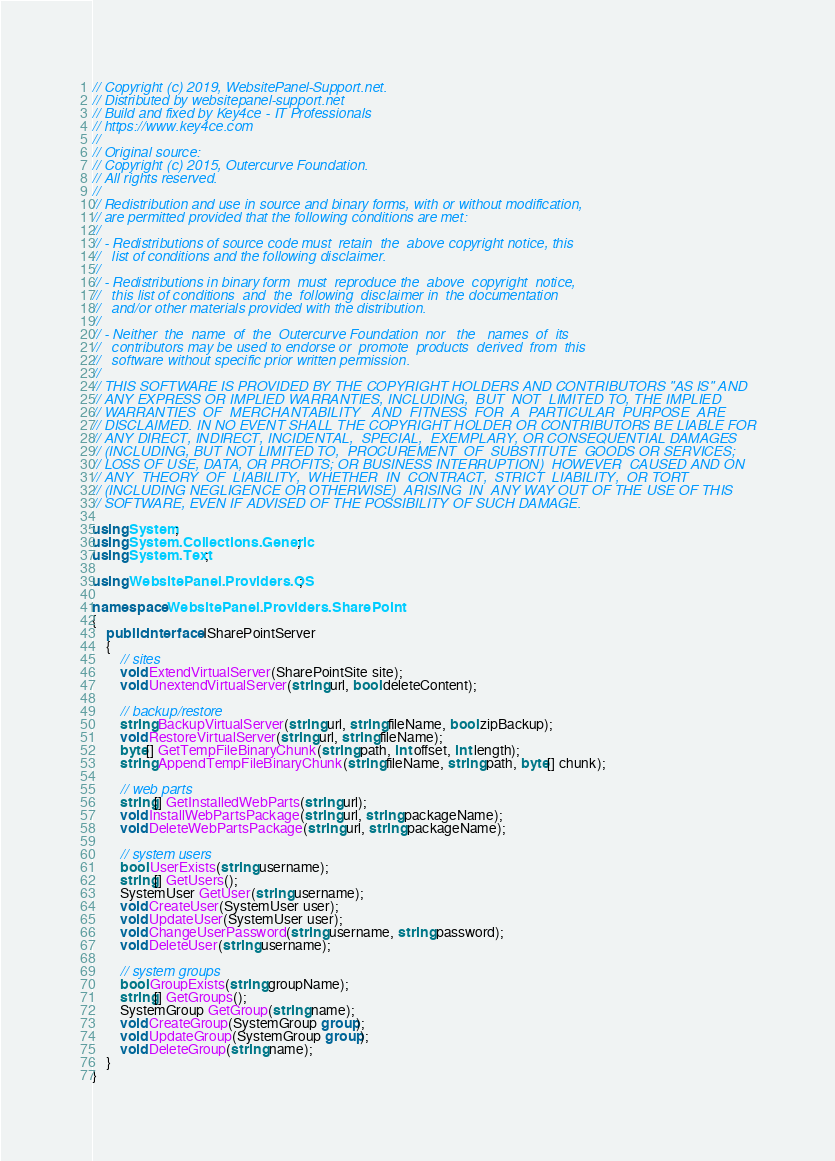<code> <loc_0><loc_0><loc_500><loc_500><_C#_>// Copyright (c) 2019, WebsitePanel-Support.net.
// Distributed by websitepanel-support.net
// Build and fixed by Key4ce - IT Professionals
// https://www.key4ce.com
// 
// Original source:
// Copyright (c) 2015, Outercurve Foundation.
// All rights reserved.
//
// Redistribution and use in source and binary forms, with or without modification,
// are permitted provided that the following conditions are met:
//
// - Redistributions of source code must  retain  the  above copyright notice, this
//   list of conditions and the following disclaimer.
//
// - Redistributions in binary form  must  reproduce the  above  copyright  notice,
//   this list of conditions  and  the  following  disclaimer in  the documentation
//   and/or other materials provided with the distribution.
//
// - Neither  the  name  of  the  Outercurve Foundation  nor   the   names  of  its
//   contributors may be used to endorse or  promote  products  derived  from  this
//   software without specific prior written permission.
//
// THIS SOFTWARE IS PROVIDED BY THE COPYRIGHT HOLDERS AND CONTRIBUTORS "AS IS" AND
// ANY EXPRESS OR IMPLIED WARRANTIES, INCLUDING,  BUT  NOT  LIMITED TO, THE IMPLIED
// WARRANTIES  OF  MERCHANTABILITY   AND  FITNESS  FOR  A  PARTICULAR  PURPOSE  ARE
// DISCLAIMED. IN NO EVENT SHALL THE COPYRIGHT HOLDER OR CONTRIBUTORS BE LIABLE FOR
// ANY DIRECT, INDIRECT, INCIDENTAL,  SPECIAL,  EXEMPLARY, OR CONSEQUENTIAL DAMAGES
// (INCLUDING, BUT NOT LIMITED TO,  PROCUREMENT  OF  SUBSTITUTE  GOODS OR SERVICES;
// LOSS OF USE, DATA, OR PROFITS; OR BUSINESS INTERRUPTION)  HOWEVER  CAUSED AND ON
// ANY  THEORY  OF  LIABILITY,  WHETHER  IN  CONTRACT,  STRICT  LIABILITY,  OR TORT
// (INCLUDING NEGLIGENCE OR OTHERWISE)  ARISING  IN  ANY WAY OUT OF THE USE OF THIS
// SOFTWARE, EVEN IF ADVISED OF THE POSSIBILITY OF SUCH DAMAGE.

using System;
using System.Collections.Generic;
using System.Text;

using WebsitePanel.Providers.OS;

namespace WebsitePanel.Providers.SharePoint
{
    public interface ISharePointServer
    {
        // sites
        void ExtendVirtualServer(SharePointSite site);
        void UnextendVirtualServer(string url, bool deleteContent);

        // backup/restore
        string BackupVirtualServer(string url, string fileName, bool zipBackup);
        void RestoreVirtualServer(string url, string fileName);
        byte[] GetTempFileBinaryChunk(string path, int offset, int length);
        string AppendTempFileBinaryChunk(string fileName, string path, byte[] chunk);

        // web parts
        string[] GetInstalledWebParts(string url);
        void InstallWebPartsPackage(string url, string packageName);
        void DeleteWebPartsPackage(string url, string packageName);

        // system users
        bool UserExists(string username);
        string[] GetUsers();
        SystemUser GetUser(string username);
        void CreateUser(SystemUser user);
        void UpdateUser(SystemUser user);
        void ChangeUserPassword(string username, string password);
        void DeleteUser(string username);

        // system groups
        bool GroupExists(string groupName);
        string[] GetGroups();
        SystemGroup GetGroup(string name);
        void CreateGroup(SystemGroup group);
        void UpdateGroup(SystemGroup group);
        void DeleteGroup(string name);
    }
}
</code> 